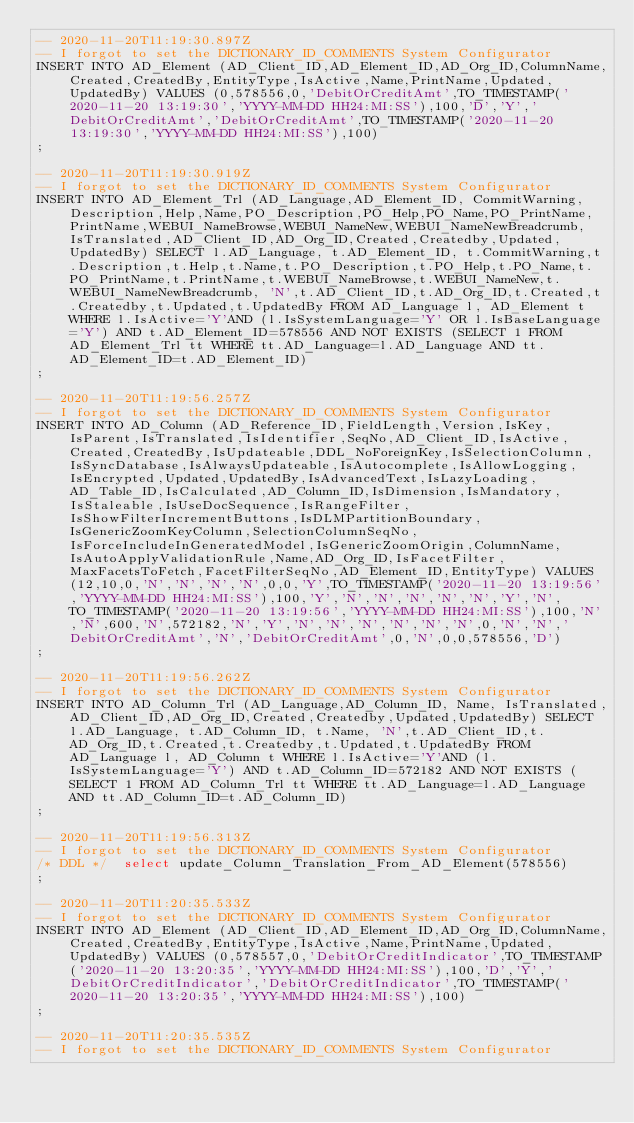<code> <loc_0><loc_0><loc_500><loc_500><_SQL_>-- 2020-11-20T11:19:30.897Z
-- I forgot to set the DICTIONARY_ID_COMMENTS System Configurator
INSERT INTO AD_Element (AD_Client_ID,AD_Element_ID,AD_Org_ID,ColumnName,Created,CreatedBy,EntityType,IsActive,Name,PrintName,Updated,UpdatedBy) VALUES (0,578556,0,'DebitOrCreditAmt',TO_TIMESTAMP('2020-11-20 13:19:30','YYYY-MM-DD HH24:MI:SS'),100,'D','Y','DebitOrCreditAmt','DebitOrCreditAmt',TO_TIMESTAMP('2020-11-20 13:19:30','YYYY-MM-DD HH24:MI:SS'),100)
;

-- 2020-11-20T11:19:30.919Z
-- I forgot to set the DICTIONARY_ID_COMMENTS System Configurator
INSERT INTO AD_Element_Trl (AD_Language,AD_Element_ID, CommitWarning,Description,Help,Name,PO_Description,PO_Help,PO_Name,PO_PrintName,PrintName,WEBUI_NameBrowse,WEBUI_NameNew,WEBUI_NameNewBreadcrumb, IsTranslated,AD_Client_ID,AD_Org_ID,Created,Createdby,Updated,UpdatedBy) SELECT l.AD_Language, t.AD_Element_ID, t.CommitWarning,t.Description,t.Help,t.Name,t.PO_Description,t.PO_Help,t.PO_Name,t.PO_PrintName,t.PrintName,t.WEBUI_NameBrowse,t.WEBUI_NameNew,t.WEBUI_NameNewBreadcrumb, 'N',t.AD_Client_ID,t.AD_Org_ID,t.Created,t.Createdby,t.Updated,t.UpdatedBy FROM AD_Language l, AD_Element t WHERE l.IsActive='Y'AND (l.IsSystemLanguage='Y' OR l.IsBaseLanguage='Y') AND t.AD_Element_ID=578556 AND NOT EXISTS (SELECT 1 FROM AD_Element_Trl tt WHERE tt.AD_Language=l.AD_Language AND tt.AD_Element_ID=t.AD_Element_ID)
;

-- 2020-11-20T11:19:56.257Z
-- I forgot to set the DICTIONARY_ID_COMMENTS System Configurator
INSERT INTO AD_Column (AD_Reference_ID,FieldLength,Version,IsKey,IsParent,IsTranslated,IsIdentifier,SeqNo,AD_Client_ID,IsActive,Created,CreatedBy,IsUpdateable,DDL_NoForeignKey,IsSelectionColumn,IsSyncDatabase,IsAlwaysUpdateable,IsAutocomplete,IsAllowLogging,IsEncrypted,Updated,UpdatedBy,IsAdvancedText,IsLazyLoading,AD_Table_ID,IsCalculated,AD_Column_ID,IsDimension,IsMandatory,IsStaleable,IsUseDocSequence,IsRangeFilter,IsShowFilterIncrementButtons,IsDLMPartitionBoundary,IsGenericZoomKeyColumn,SelectionColumnSeqNo,IsForceIncludeInGeneratedModel,IsGenericZoomOrigin,ColumnName,IsAutoApplyValidationRule,Name,AD_Org_ID,IsFacetFilter,MaxFacetsToFetch,FacetFilterSeqNo,AD_Element_ID,EntityType) VALUES (12,10,0,'N','N','N','N',0,0,'Y',TO_TIMESTAMP('2020-11-20 13:19:56','YYYY-MM-DD HH24:MI:SS'),100,'Y','N','N','N','N','N','Y','N',TO_TIMESTAMP('2020-11-20 13:19:56','YYYY-MM-DD HH24:MI:SS'),100,'N','N',600,'N',572182,'N','Y','N','N','N','N','N','N',0,'N','N','DebitOrCreditAmt','N','DebitOrCreditAmt',0,'N',0,0,578556,'D')
;

-- 2020-11-20T11:19:56.262Z
-- I forgot to set the DICTIONARY_ID_COMMENTS System Configurator
INSERT INTO AD_Column_Trl (AD_Language,AD_Column_ID, Name, IsTranslated,AD_Client_ID,AD_Org_ID,Created,Createdby,Updated,UpdatedBy) SELECT l.AD_Language, t.AD_Column_ID, t.Name, 'N',t.AD_Client_ID,t.AD_Org_ID,t.Created,t.Createdby,t.Updated,t.UpdatedBy FROM AD_Language l, AD_Column t WHERE l.IsActive='Y'AND (l.IsSystemLanguage='Y') AND t.AD_Column_ID=572182 AND NOT EXISTS (SELECT 1 FROM AD_Column_Trl tt WHERE tt.AD_Language=l.AD_Language AND tt.AD_Column_ID=t.AD_Column_ID)
;

-- 2020-11-20T11:19:56.313Z
-- I forgot to set the DICTIONARY_ID_COMMENTS System Configurator
/* DDL */  select update_Column_Translation_From_AD_Element(578556) 
;

-- 2020-11-20T11:20:35.533Z
-- I forgot to set the DICTIONARY_ID_COMMENTS System Configurator
INSERT INTO AD_Element (AD_Client_ID,AD_Element_ID,AD_Org_ID,ColumnName,Created,CreatedBy,EntityType,IsActive,Name,PrintName,Updated,UpdatedBy) VALUES (0,578557,0,'DebitOrCreditIndicator',TO_TIMESTAMP('2020-11-20 13:20:35','YYYY-MM-DD HH24:MI:SS'),100,'D','Y','DebitOrCreditIndicator','DebitOrCreditIndicator',TO_TIMESTAMP('2020-11-20 13:20:35','YYYY-MM-DD HH24:MI:SS'),100)
;

-- 2020-11-20T11:20:35.535Z
-- I forgot to set the DICTIONARY_ID_COMMENTS System Configurator</code> 